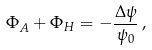<formula> <loc_0><loc_0><loc_500><loc_500>\Phi _ { A } + \Phi _ { H } = - \frac { \Delta \psi } { \psi _ { 0 } } \, ,</formula> 